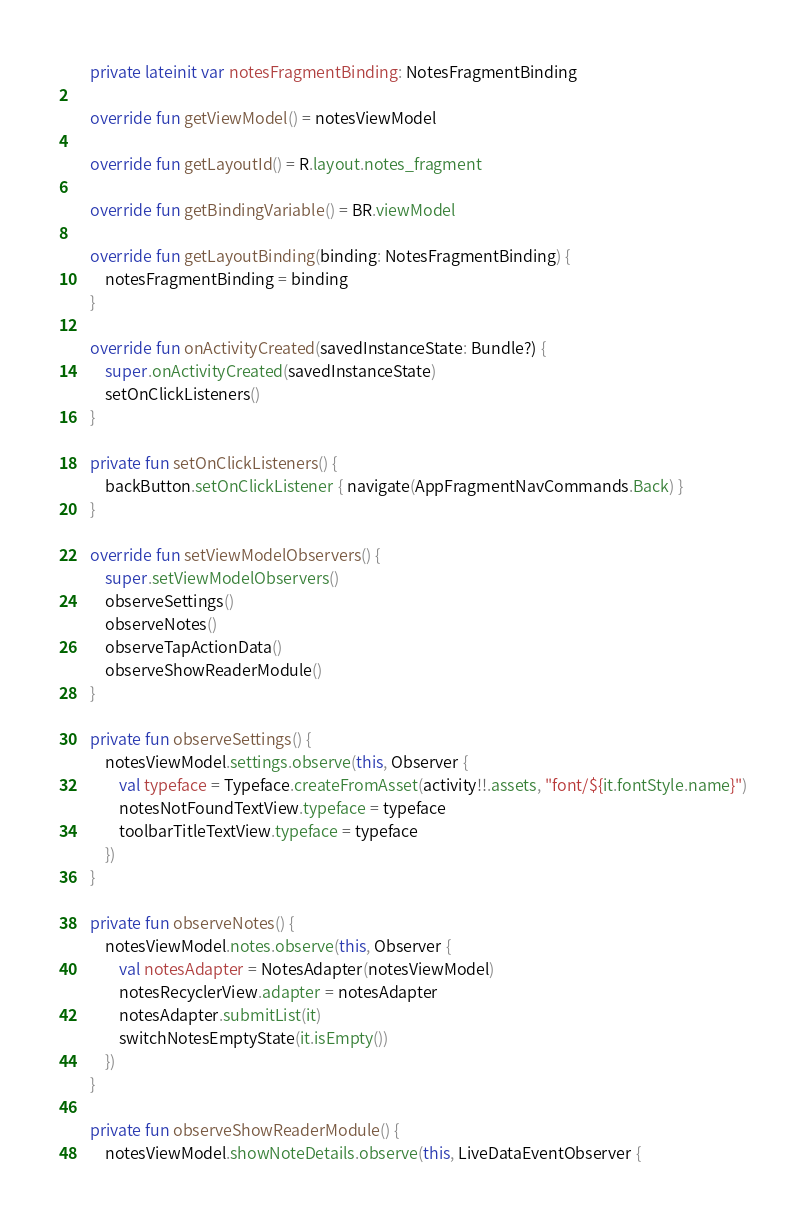Convert code to text. <code><loc_0><loc_0><loc_500><loc_500><_Kotlin_>
    private lateinit var notesFragmentBinding: NotesFragmentBinding

    override fun getViewModel() = notesViewModel

    override fun getLayoutId() = R.layout.notes_fragment

    override fun getBindingVariable() = BR.viewModel

    override fun getLayoutBinding(binding: NotesFragmentBinding) {
        notesFragmentBinding = binding
    }

    override fun onActivityCreated(savedInstanceState: Bundle?) {
        super.onActivityCreated(savedInstanceState)
        setOnClickListeners()
    }

    private fun setOnClickListeners() {
        backButton.setOnClickListener { navigate(AppFragmentNavCommands.Back) }
    }

    override fun setViewModelObservers() {
        super.setViewModelObservers()
        observeSettings()
        observeNotes()
        observeTapActionData()
        observeShowReaderModule()
    }

    private fun observeSettings() {
        notesViewModel.settings.observe(this, Observer {
            val typeface = Typeface.createFromAsset(activity!!.assets, "font/${it.fontStyle.name}")
            notesNotFoundTextView.typeface = typeface
            toolbarTitleTextView.typeface = typeface
        })
    }

    private fun observeNotes() {
        notesViewModel.notes.observe(this, Observer {
            val notesAdapter = NotesAdapter(notesViewModel)
            notesRecyclerView.adapter = notesAdapter
            notesAdapter.submitList(it)
            switchNotesEmptyState(it.isEmpty())
        })
    }

    private fun observeShowReaderModule() {
        notesViewModel.showNoteDetails.observe(this, LiveDataEventObserver {</code> 